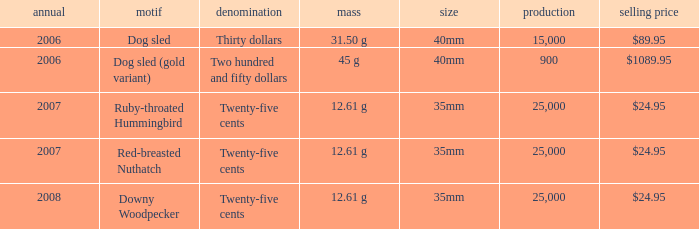What is the Diameter of the Dog Sled (gold variant) Theme coin? 40mm. 